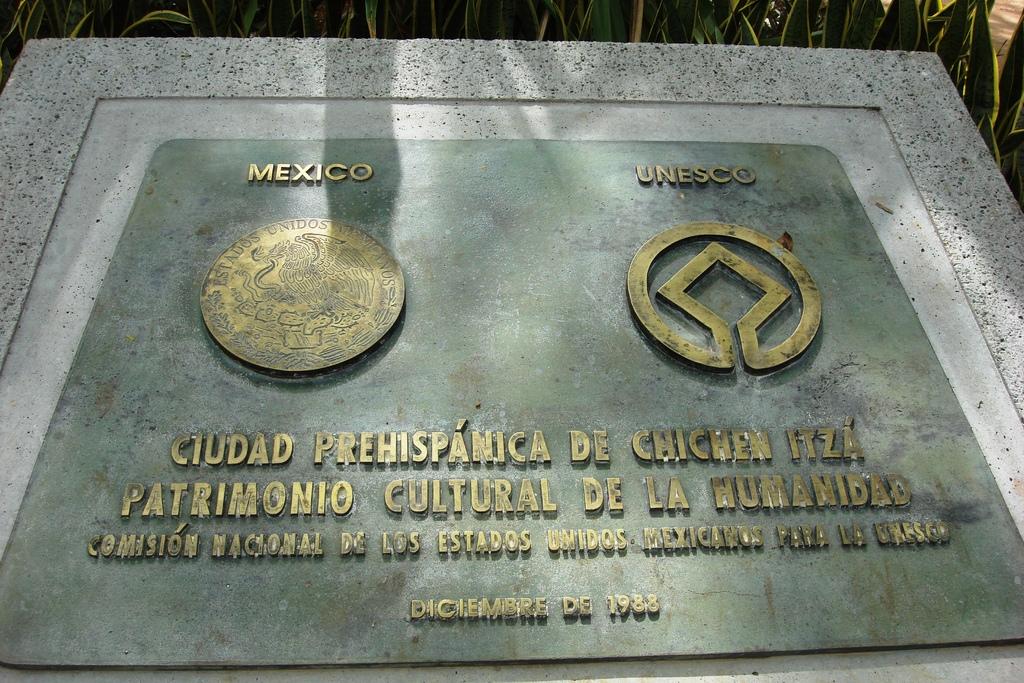What year was this plague put in?
Your answer should be very brief. 1988. 